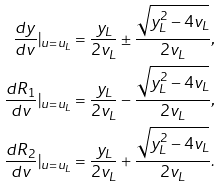<formula> <loc_0><loc_0><loc_500><loc_500>\frac { d y } { d v } | _ { u = u _ { L } } & = \frac { y _ { L } } { 2 v _ { L } } \pm \frac { \sqrt { y _ { L } ^ { 2 } - 4 v _ { L } } } { 2 v _ { L } } , \\ \frac { d R _ { 1 } } { d v } | _ { u = u _ { L } } & = \frac { y _ { L } } { 2 v _ { L } } - \frac { \sqrt { y _ { L } ^ { 2 } - 4 v _ { L } } } { 2 v _ { L } } , \\ \frac { d R _ { 2 } } { d v } | _ { u = u _ { L } } & = \frac { y _ { L } } { 2 v _ { L } } + \frac { \sqrt { y _ { L } ^ { 2 } - 4 v _ { L } } } { 2 v _ { L } } .</formula> 